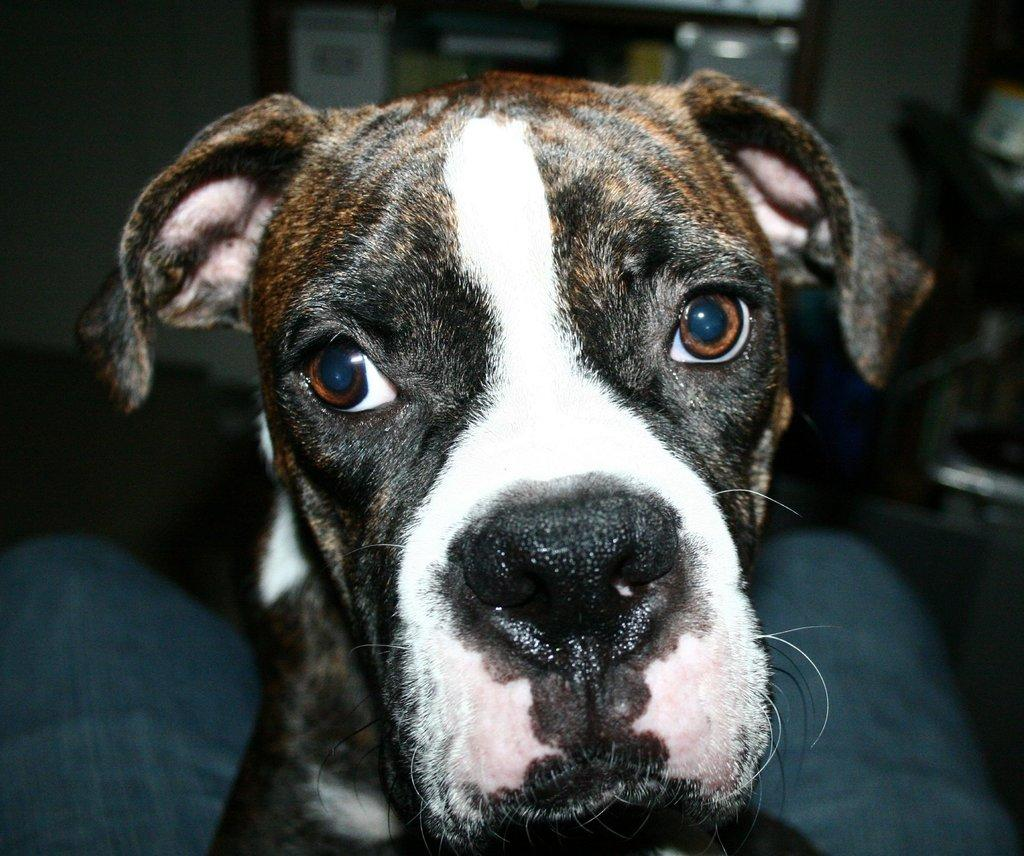What type of animal is in the image? There is a black and white dog in the image. Can you describe the background of the image? The background is blurred. Where is the meeting taking place in the image? There is no meeting present in the image; it only features a black and white dog. What type of grass can be seen in the image? There is no grass visible in the image; it only features a black and white dog and a blurred background. 